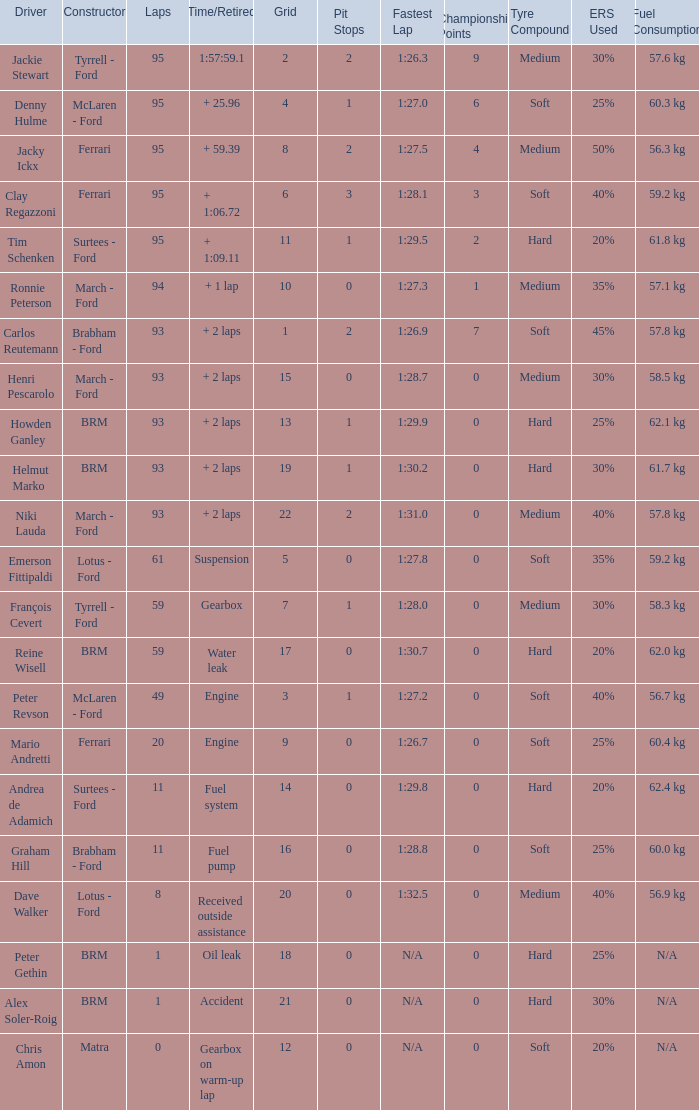How many grids does dave walker have? 1.0. 